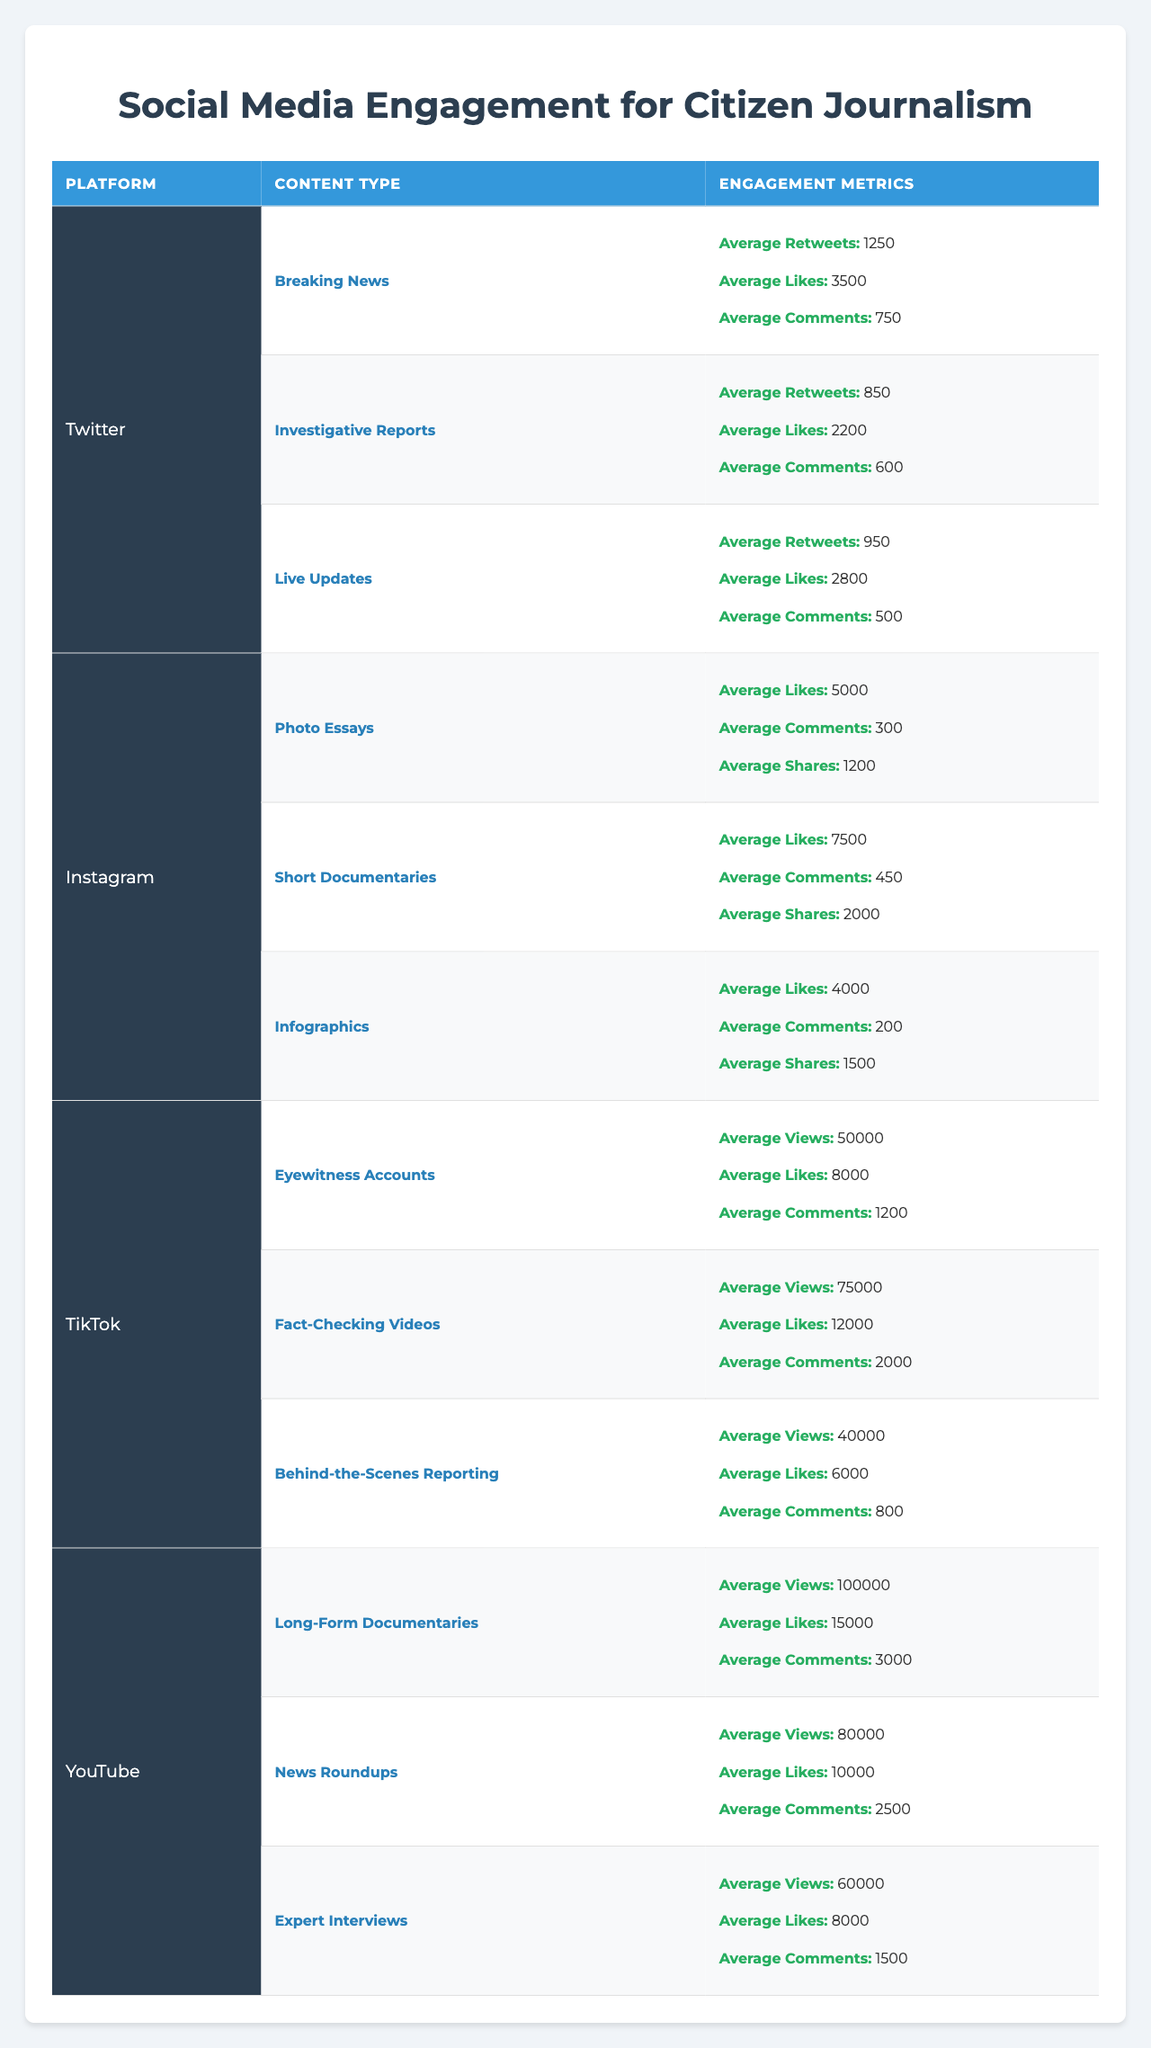What is the average number of likes for "Breaking News" content on Twitter? The data shows that "Breaking News" on Twitter has an average of 3500 likes. Since there's only one value for this content type, the average is simply 3500.
Answer: 3500 Which type of content on Instagram has the highest average number of likes? The different types of content on Instagram are Photo Essays (5000 likes), Short Documentaries (7500 likes), and Infographics (4000 likes). The highest average likes are for Short Documentaries with 7500 likes.
Answer: Short Documentaries How many total views do "Fact-Checking Videos" and "Behind-the-Scenes Reporting" have on TikTok combined? "Fact-Checking Videos" has 75000 views and "Behind-the-Scenes Reporting" has 40000 views. Adding those together: 75000 + 40000 = 115000.
Answer: 115000 True or False: The average number of comments for "News Roundups" on YouTube is higher than that for "Long-Form Documentaries." "News Roundups" has 2500 comments while "Long-Form Documentaries" has 3000 comments. Since 2500 is not higher than 3000, the statement is false.
Answer: False What is the overall average number of likes across all content types on Instagram? The likes for each content type on Instagram are: 5000 (Photo Essays), 7500 (Short Documentaries), and 4000 (Infographics). The total likes are 5000 + 7500 + 4000 = 26500, divided by 3 types gives an average of 26500 / 3 = 8833.33. Rounded, it is approximately 8833.
Answer: 8833 On which platform do "Live Updates" receive more average likes compared to "Investigative Reports"? On Twitter, "Live Updates" have 2800 likes, while "Investigative Reports" have 2200 likes. Since 2800 is greater than 2200, "Live Updates" receive more likes than "Investigative Reports" on Twitter.
Answer: Twitter Which type of content generally has the highest engagement metrics, and how do you define "engagement metrics"? Comparing data from different categories, TikTok's "Fact-Checking Videos" have an average of 75000 views, 12000 likes, and 2000 comments, making it likely the type with the highest engagement metrics. Engagement metrics are typically defined as metrics like likes, shares, views, and comments that show how the audience interacts with content.
Answer: Fact-Checking Videos How many more average retweets does "Breaking News" have compared to "Live Updates" on Twitter? "Breaking News" has 1250 retweets, and "Live Updates" has 950. The difference is calculated as 1250 - 950 = 300.
Answer: 300 What is the average number of comments for all citizen journalism content types on TikTok? The average comments for TikTok content types are: Eyewitness Accounts (1200), Fact-Checking Videos (2000), and Behind-the-Scenes Reporting (800). Summing these gives: 1200 + 2000 + 800 = 4000, divided by 3 gives 4000 / 3 = 1333.33. Rounded off, it’s approximately 1333.
Answer: 1333 Which platform has the least engagement for investigative journalism content based on likes? Investigative Reports on Twitter have an average of 2200 likes, which is less than other types across all platforms. Therefore, Twitter has the least engagement for investigative content based on likes.
Answer: Twitter 